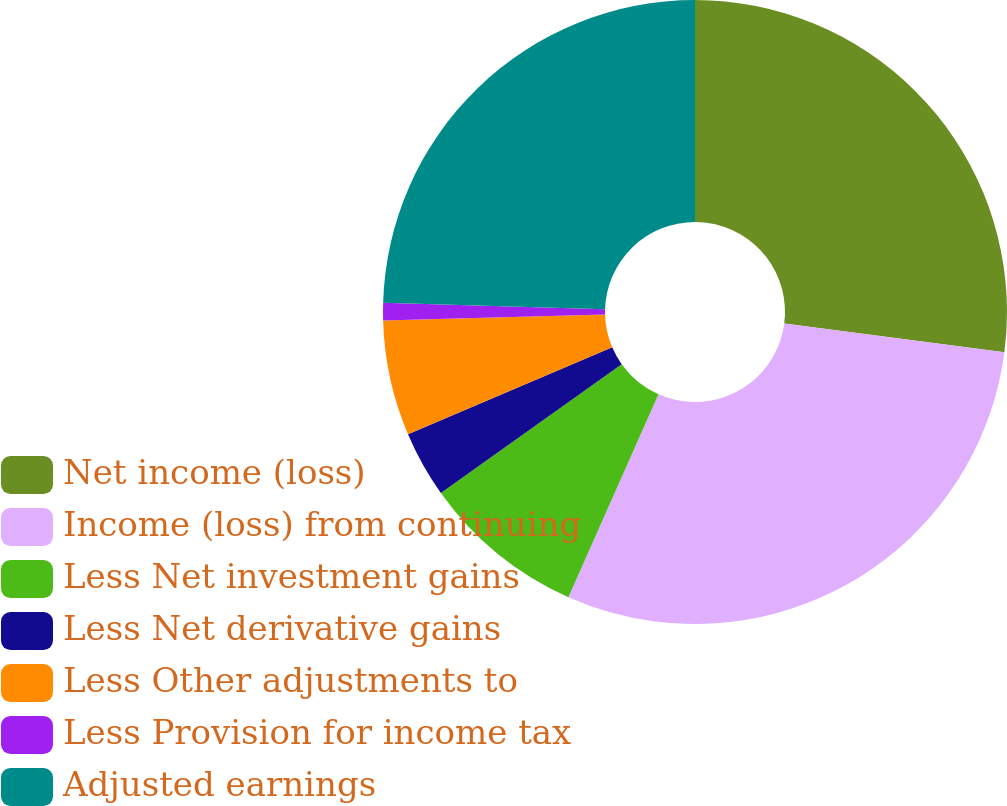Convert chart to OTSL. <chart><loc_0><loc_0><loc_500><loc_500><pie_chart><fcel>Net income (loss)<fcel>Income (loss) from continuing<fcel>Less Net investment gains<fcel>Less Net derivative gains<fcel>Less Other adjustments to<fcel>Less Provision for income tax<fcel>Adjusted earnings<nl><fcel>27.06%<fcel>29.59%<fcel>8.5%<fcel>3.44%<fcel>5.97%<fcel>0.91%<fcel>24.53%<nl></chart> 